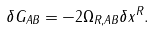<formula> <loc_0><loc_0><loc_500><loc_500>\delta G _ { A B } = - 2 \Omega _ { R , A B } \delta x ^ { R } .</formula> 